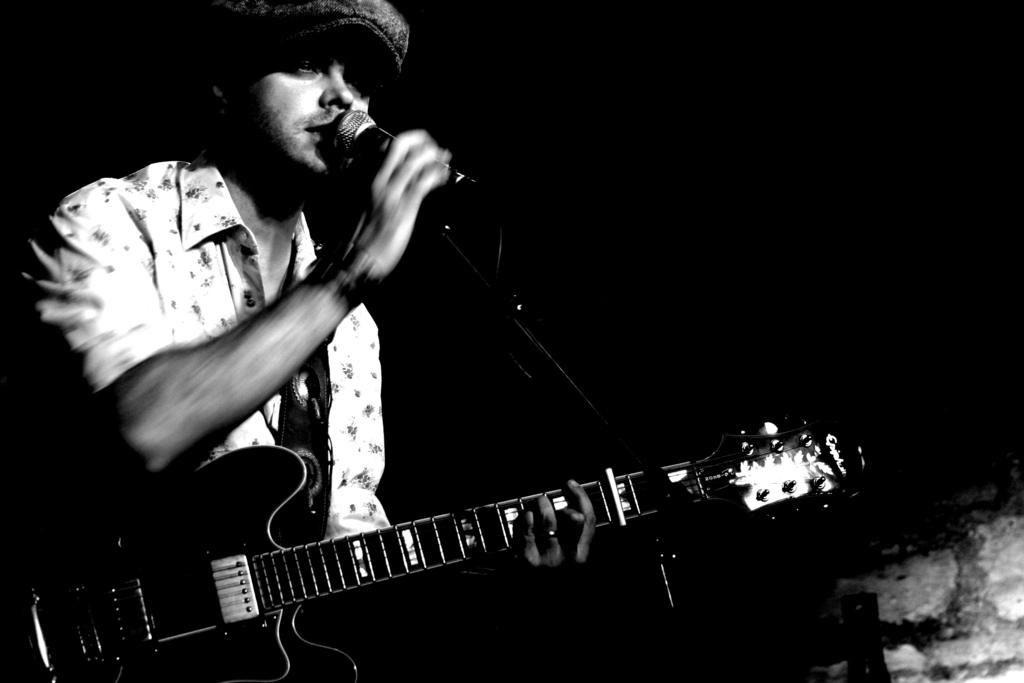Who is the main subject in the image? There is a man in the image. Where is the man positioned in the image? The man is standing on the left side. What is the man holding in the image? The man is holding a black music instrument. What is the man doing with the microphone in the image? The man is singing into a microphone. What type of cherries can be seen in the man's hand in the image? There are no cherries present in the image; the man is holding a black music instrument. How does the man's impulse to sing affect the school environment in the image? There is no reference to a school or any educational environment in the image, so it's not possible to determine how the man's impulse to sing might affect it. 